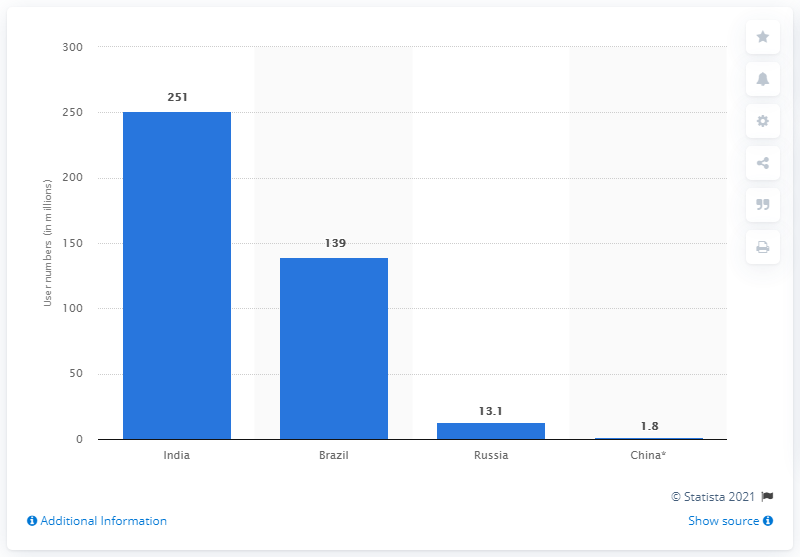Point out several critical features in this image. In June 2018, there were 251 people using Facebook in India. 